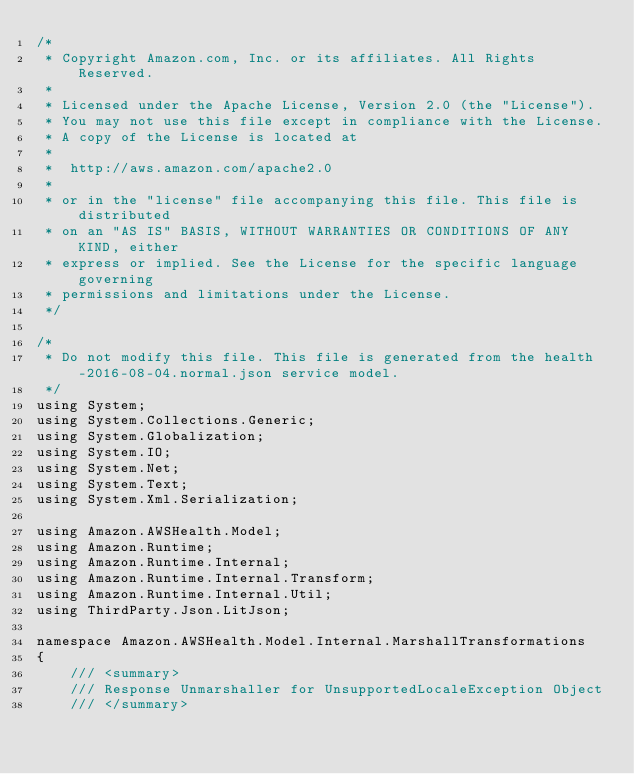Convert code to text. <code><loc_0><loc_0><loc_500><loc_500><_C#_>/*
 * Copyright Amazon.com, Inc. or its affiliates. All Rights Reserved.
 * 
 * Licensed under the Apache License, Version 2.0 (the "License").
 * You may not use this file except in compliance with the License.
 * A copy of the License is located at
 * 
 *  http://aws.amazon.com/apache2.0
 * 
 * or in the "license" file accompanying this file. This file is distributed
 * on an "AS IS" BASIS, WITHOUT WARRANTIES OR CONDITIONS OF ANY KIND, either
 * express or implied. See the License for the specific language governing
 * permissions and limitations under the License.
 */

/*
 * Do not modify this file. This file is generated from the health-2016-08-04.normal.json service model.
 */
using System;
using System.Collections.Generic;
using System.Globalization;
using System.IO;
using System.Net;
using System.Text;
using System.Xml.Serialization;

using Amazon.AWSHealth.Model;
using Amazon.Runtime;
using Amazon.Runtime.Internal;
using Amazon.Runtime.Internal.Transform;
using Amazon.Runtime.Internal.Util;
using ThirdParty.Json.LitJson;

namespace Amazon.AWSHealth.Model.Internal.MarshallTransformations
{
    /// <summary>
    /// Response Unmarshaller for UnsupportedLocaleException Object
    /// </summary>  </code> 